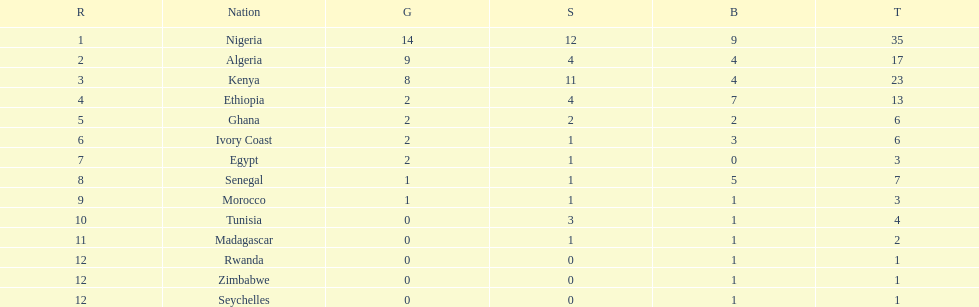The team before algeria Nigeria. 